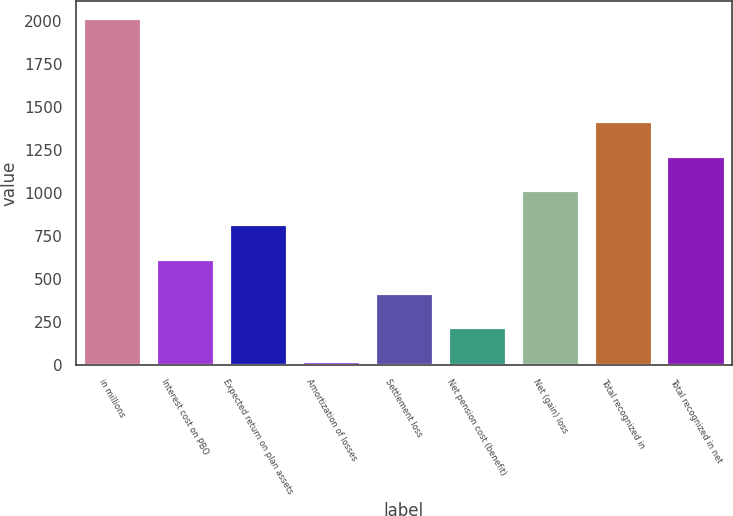Convert chart. <chart><loc_0><loc_0><loc_500><loc_500><bar_chart><fcel>in millions<fcel>Interest cost on PBO<fcel>Expected return on plan assets<fcel>Amortization of losses<fcel>Settlement loss<fcel>Net pension cost (benefit)<fcel>Net (gain) loss<fcel>Total recognized in<fcel>Total recognized in net<nl><fcel>2013<fcel>617.2<fcel>816.6<fcel>19<fcel>417.8<fcel>218.4<fcel>1016<fcel>1414.8<fcel>1215.4<nl></chart> 